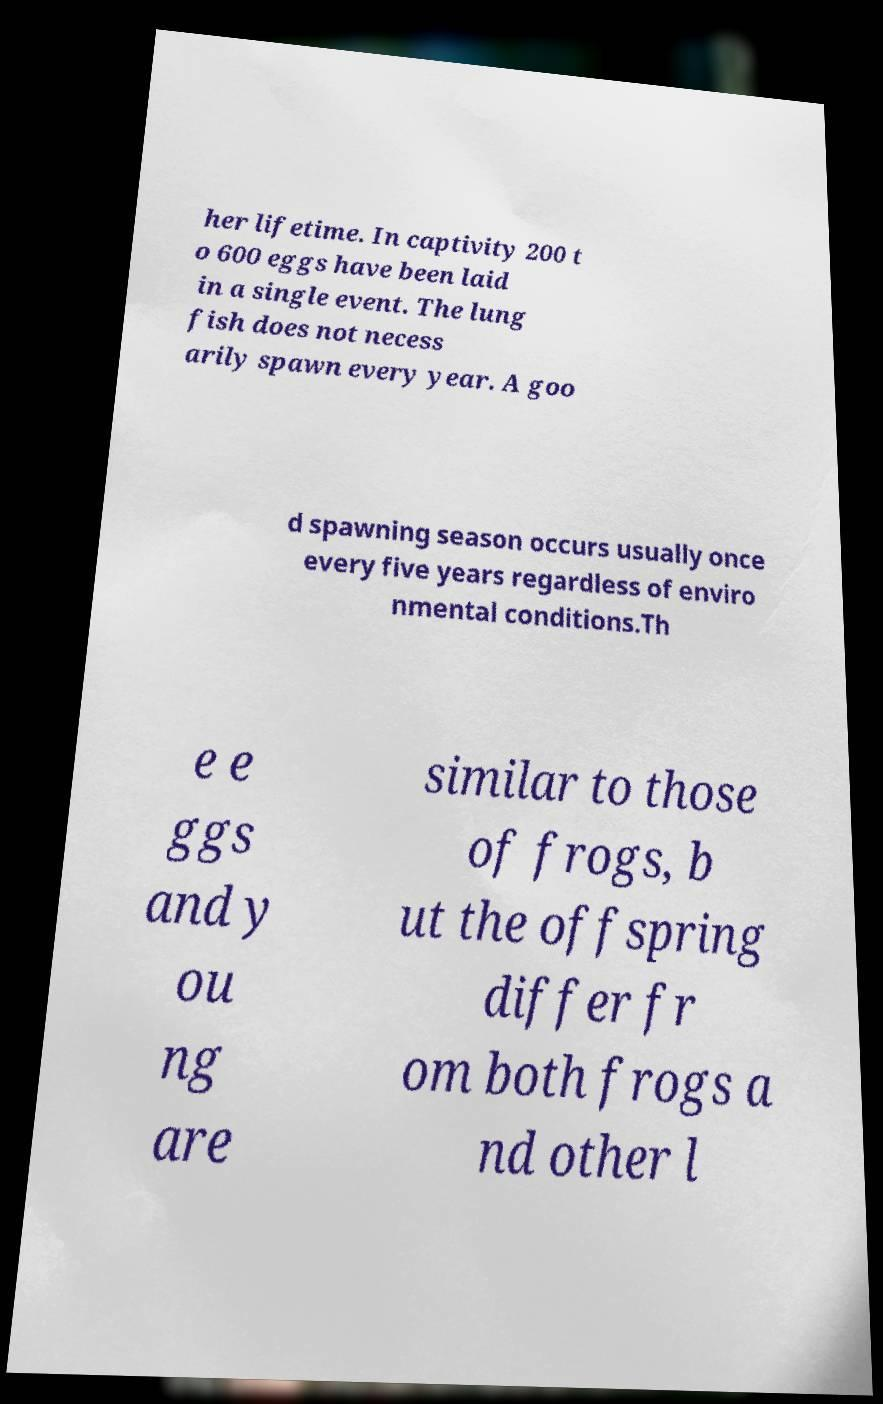Can you accurately transcribe the text from the provided image for me? her lifetime. In captivity 200 t o 600 eggs have been laid in a single event. The lung fish does not necess arily spawn every year. A goo d spawning season occurs usually once every five years regardless of enviro nmental conditions.Th e e ggs and y ou ng are similar to those of frogs, b ut the offspring differ fr om both frogs a nd other l 